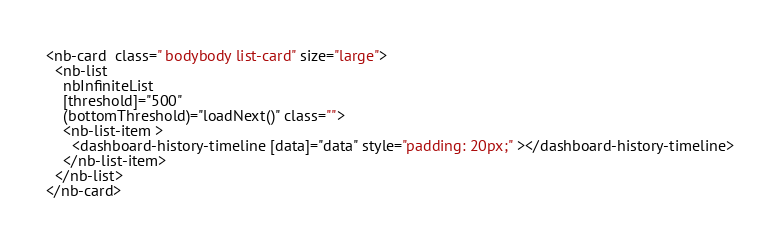Convert code to text. <code><loc_0><loc_0><loc_500><loc_500><_HTML_><nb-card  class=" bodybody list-card" size="large">
  <nb-list
    nbInfiniteList
    [threshold]="500"
    (bottomThreshold)="loadNext()" class="">
    <nb-list-item >
      <dashboard-history-timeline [data]="data" style="padding: 20px;" ></dashboard-history-timeline>
    </nb-list-item>
  </nb-list>
</nb-card>
</code> 